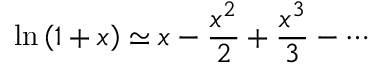Convert formula to latex. <formula><loc_0><loc_0><loc_500><loc_500>\ln \left ( 1 + x \right ) \simeq x - { \frac { x ^ { 2 } } { 2 } } + { \frac { x ^ { 3 } } { 3 } } - \cdots</formula> 